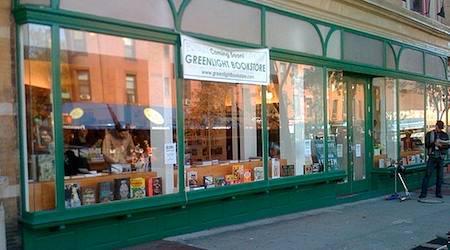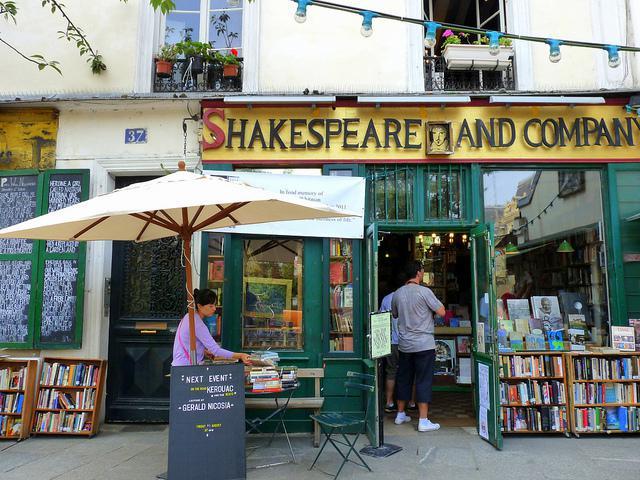The first image is the image on the left, the second image is the image on the right. For the images displayed, is the sentence "There are book shelves outside the store." factually correct? Answer yes or no. Yes. The first image is the image on the left, the second image is the image on the right. Evaluate the accuracy of this statement regarding the images: "In at least one image there is a woman with dark hair reading a book off to the left side of the outside of a bookstore with yellow trim.". Is it true? Answer yes or no. Yes. 